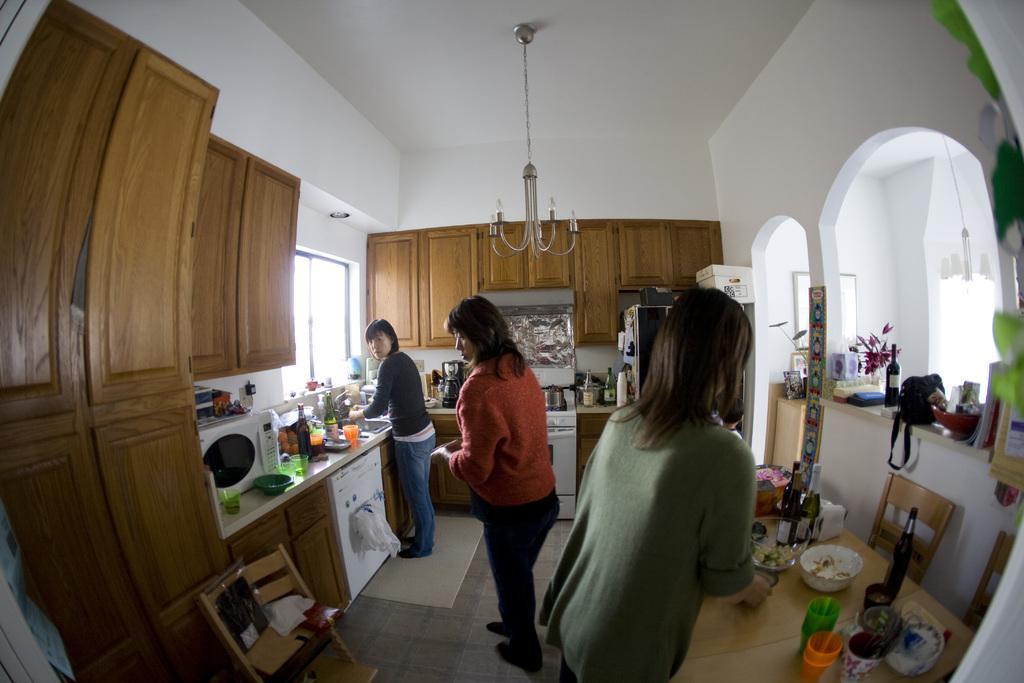Describe this image in one or two sentences. In the image we can see three women standing, wearing clothes and shoes. Here we can see bottles, glass, bowls, oven and their kitchen stuff. Here we can see wooden cupboards, floor and the window. Here we can see an arch, refrigerator, leaves and the chandelier. 